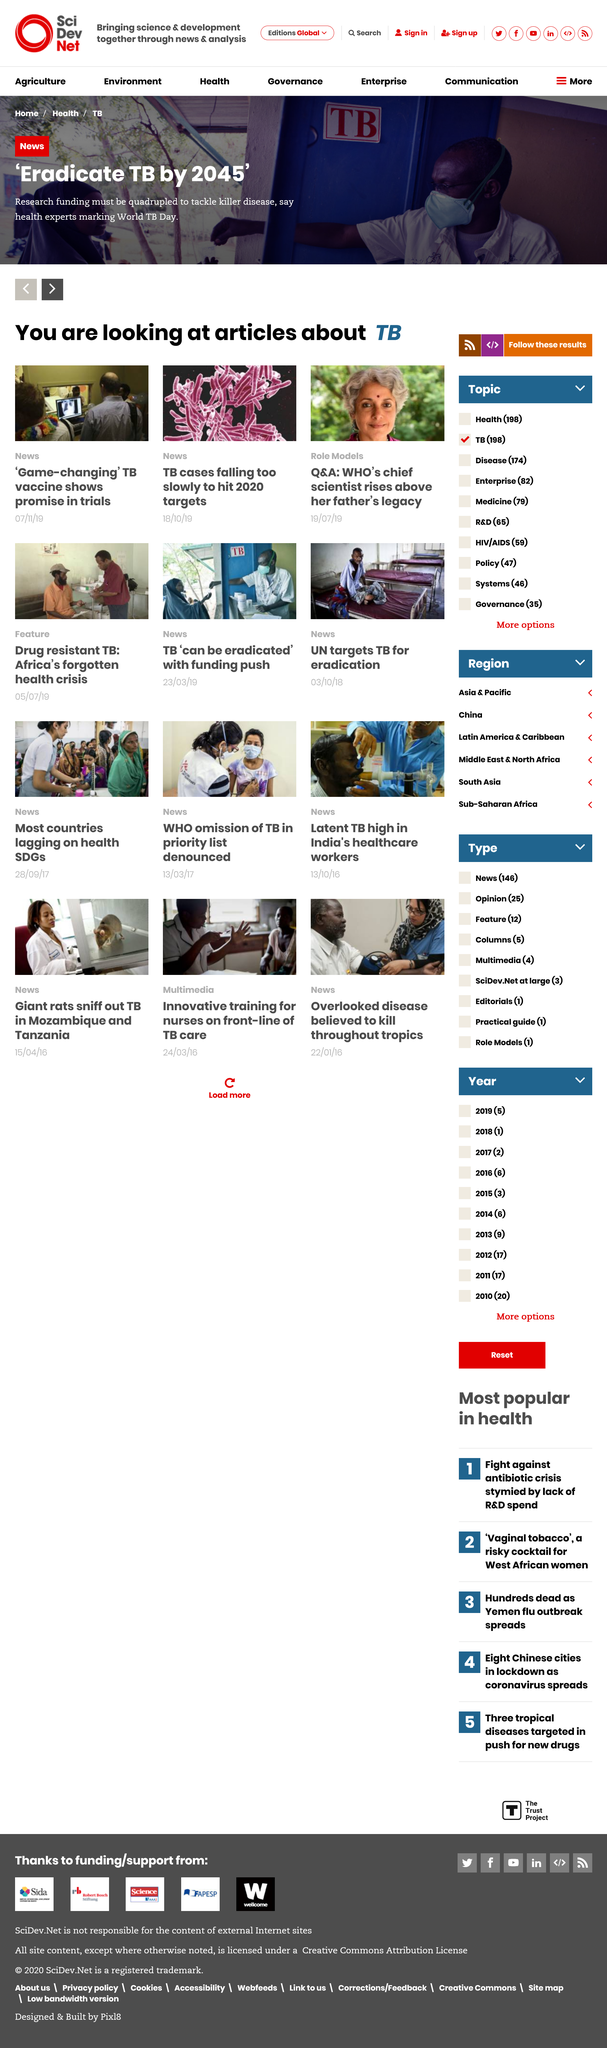Give some essential details in this illustration. Researchers predict that tuberculosis (TB) will be eradicated by 2045. This page is discussing the topic of TB. Researchers need four times the amount of funding to effectively tackle tuberculosis (TB). 